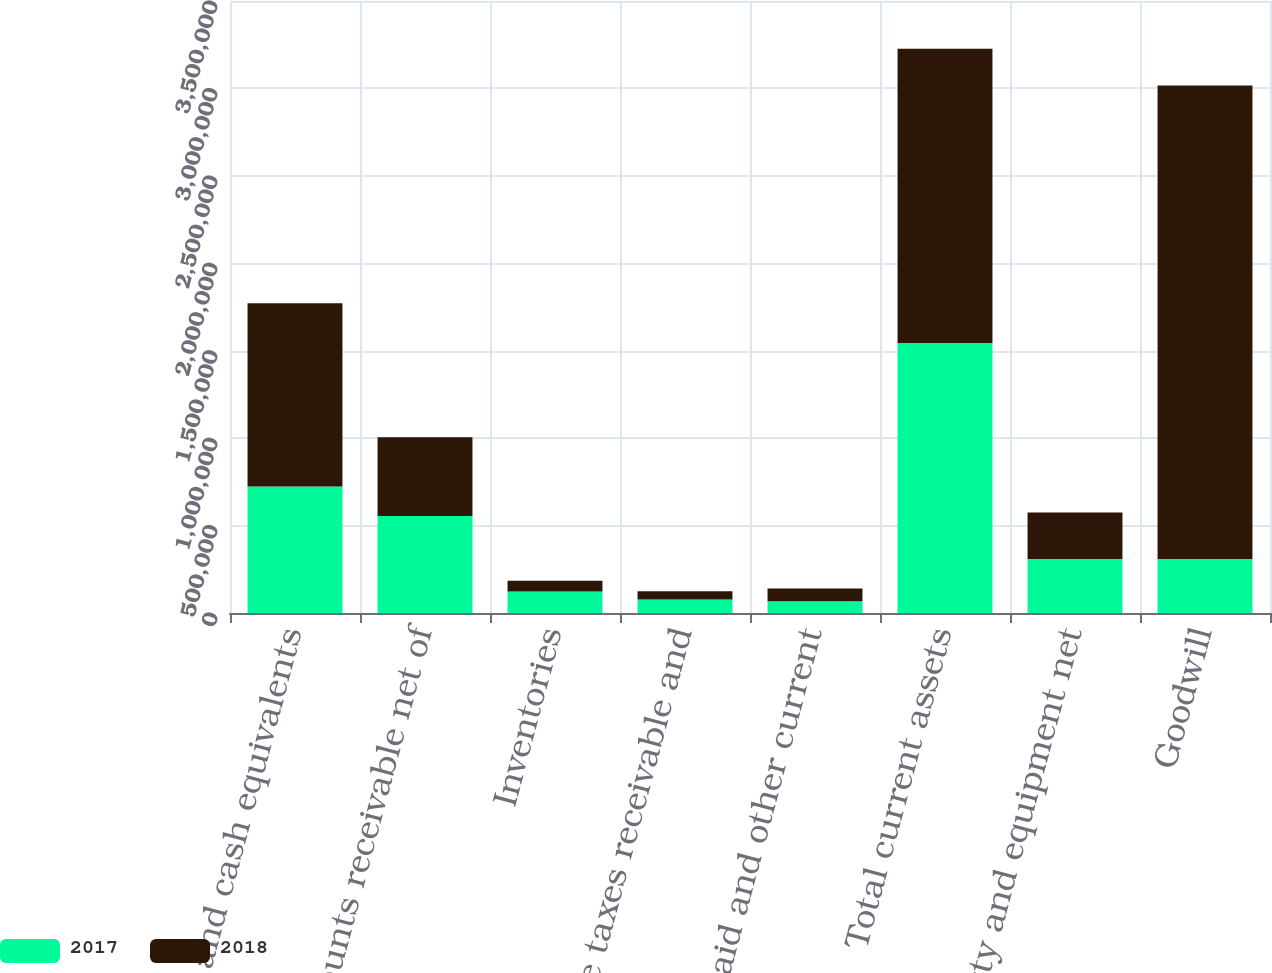<chart> <loc_0><loc_0><loc_500><loc_500><stacked_bar_chart><ecel><fcel>Cash and cash equivalents<fcel>Accounts receivable net of<fcel>Inventories<fcel>Income taxes receivable and<fcel>Prepaid and other current<fcel>Total current assets<fcel>Property and equipment net<fcel>Goodwill<nl><fcel>2017<fcel>723115<fcel>554217<fcel>122407<fcel>76525<fcel>67533<fcel>1.5438e+06<fcel>309310<fcel>309310<nl><fcel>2018<fcel>1.04836e+06<fcel>451144<fcel>61884<fcel>48257<fcel>72952<fcel>1.68259e+06<fcel>266014<fcel>2.70697e+06<nl></chart> 